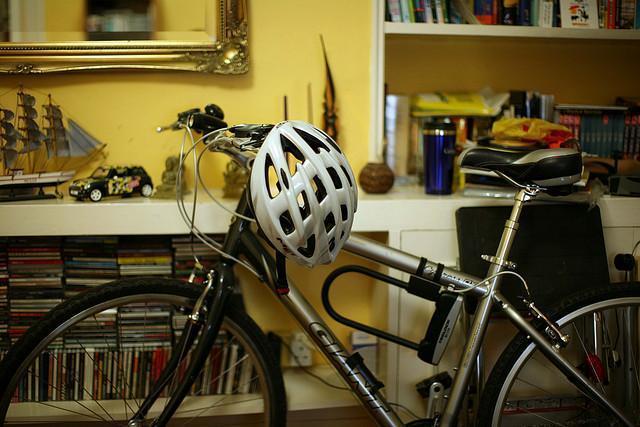How many books are there?
Give a very brief answer. 2. 